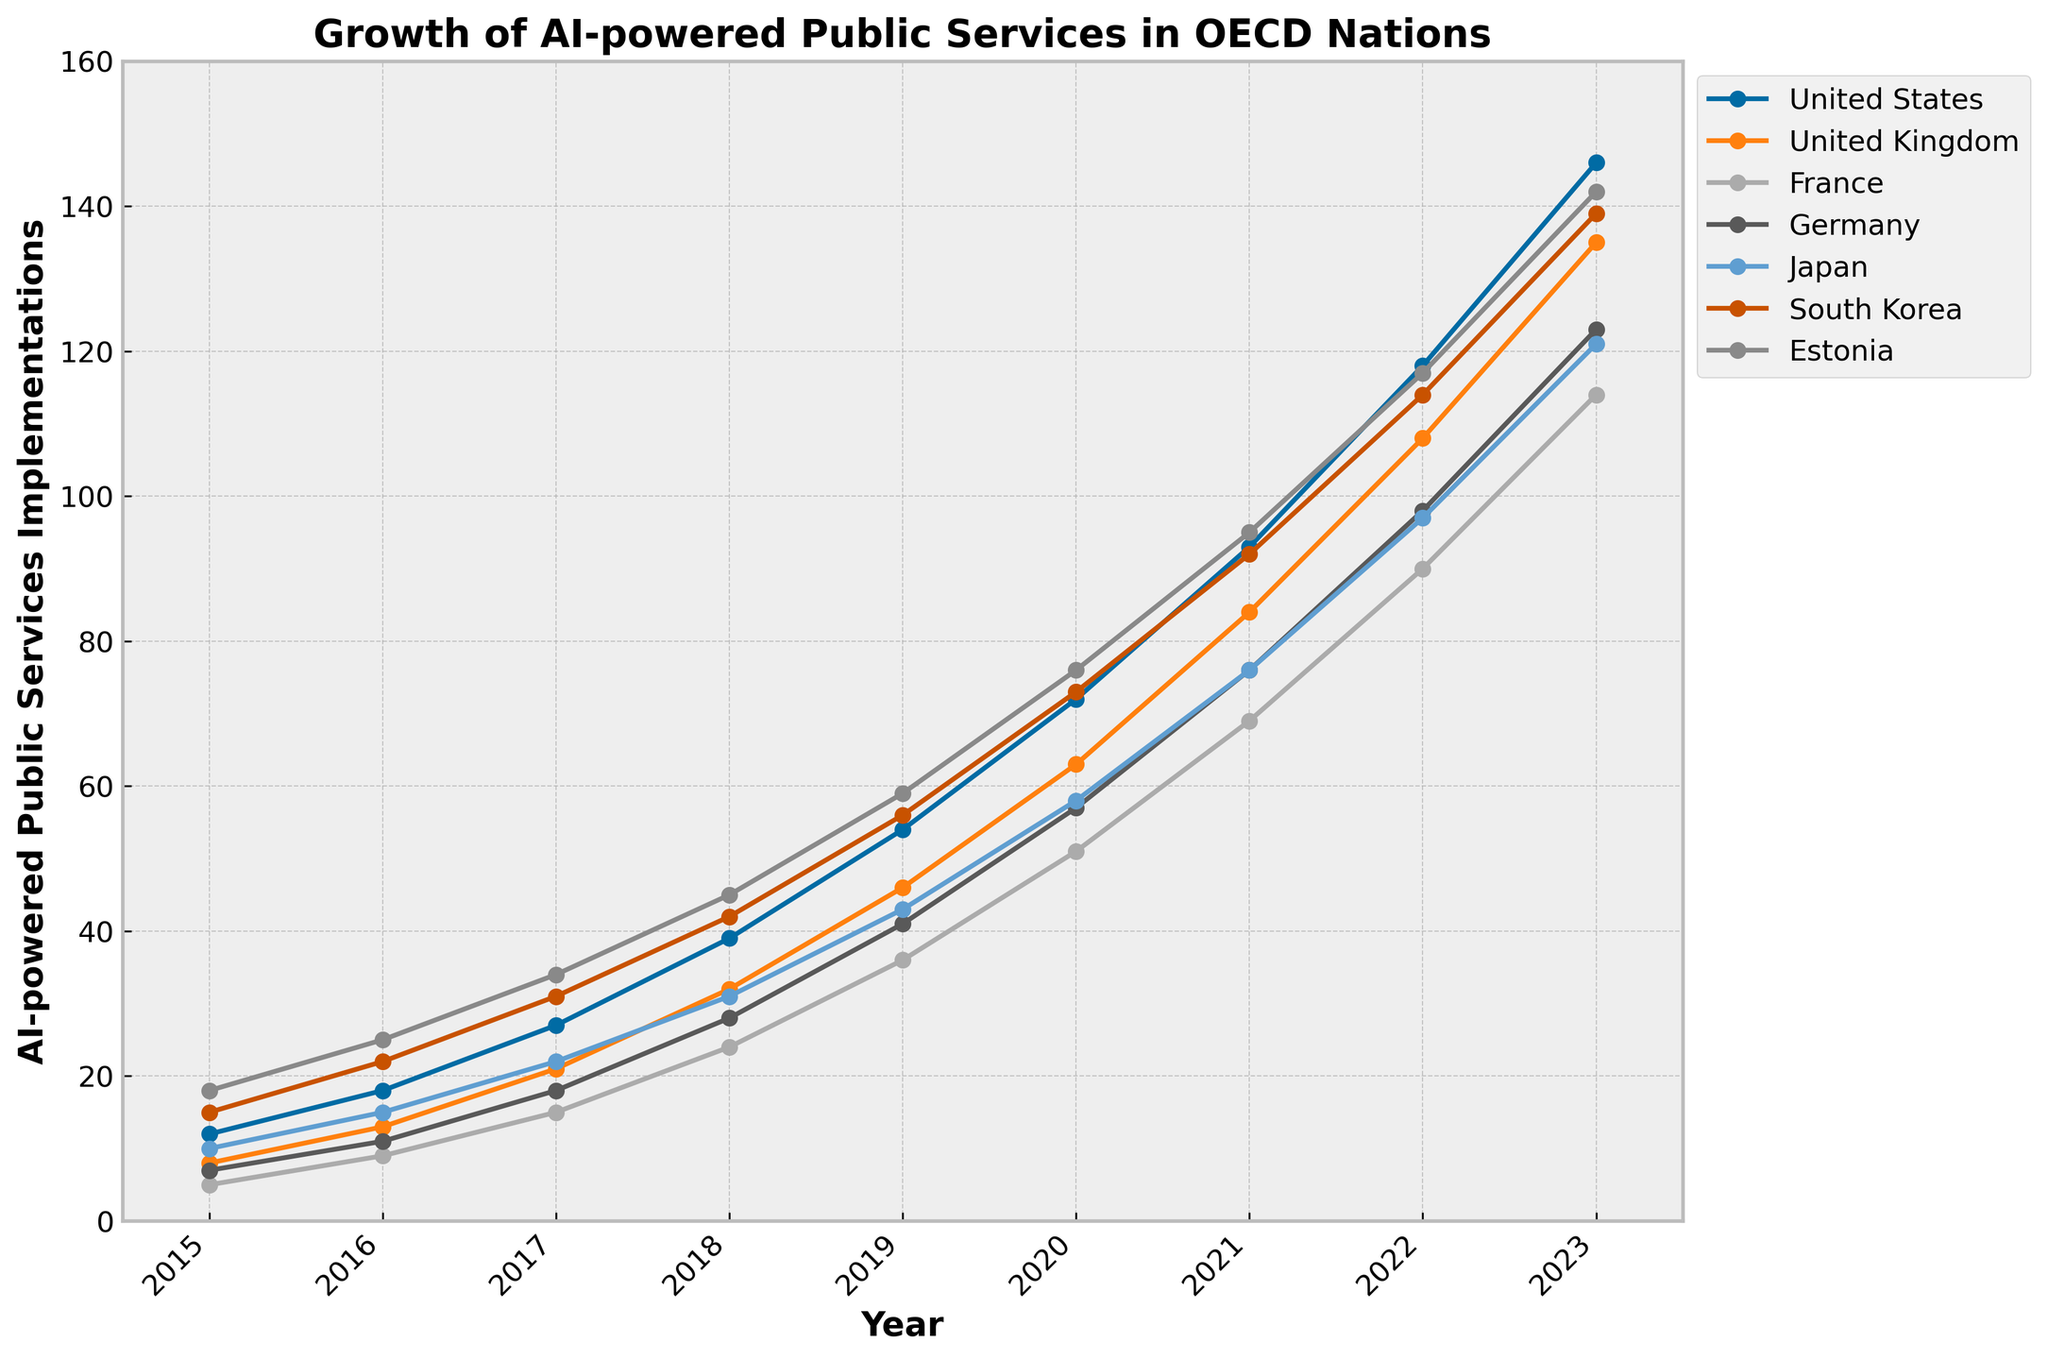Which country showed the sharpest increase in AI-powered public services implementations between 2015 and 2023? Look at the overall trend lines on the chart. Estimate the differences in the ending and starting values for each country. The United States shows the sharpest increase from 12 in 2015 to 146 in 2023.
Answer: United States How many more implementations did South Korea have compared to Germany in 2020? Identify the values for South Korea and Germany in 2020. South Korea has 73 implementations, and Germany has 57, so the difference is 73 - 57 = 16.
Answer: 16 What is the average number of implementations for Japan across the years shown? Sum the values for Japan from 2015 to 2023 and divide by the number of years (9). The total is 10 + 15 + 22 + 31 + 43 + 58 + 76 + 97 + 121 = 373. The average is 373 / 9 ≈ 41.4.
Answer: 41.4 Which country had the least implementations in 2017? Identify the implementation values for each country in 2017 and compare them. France had the least implementations with 15.
Answer: France In which year did Estonia surpass 100 implementations? Look for the point where Estonia's trend line crosses 100. This occurs in 2021 when Estonia reaches 95 and 2022 when it reaches 117.
Answer: 2022 By how much did the United States' implementations increase from 2018 to 2023? Subtract the value in 2018 from the value in 2023 for the United States. The increase is 146 - 39 = 107.
Answer: 107 Which two countries had the same number of implementations in 2021? Compare the implementation numbers for each country in 2021. Japan and Estonia both have 95 implementations.
Answer: Japan and Estonia Rank the countries in descending order of their 2023 implementation count. Check the 2023 values for all countries and order them. The order is: United States (146), South Korea (139), United Kingdom (135), Estonia (142), Germany (123), Japan (121), France (114).
Answer: United States, South Korea, United Kingdom, Estonia, Germany, Japan, France What was the percentage increase in AI-powered public services implementations in the UK from 2015 to 2020? Calculate the increase and the starting value, then find the percentage. The difference is 63 - 8 = 55. The percentage increase is (55 / 8) * 100 ≈ 687.5%.
Answer: 687.5% How many implementations did France have cumulatively from 2015 to 2023? Sum the values for France for each year. The total is 5 + 9 + 15 + 24 + 36 + 51 + 69 + 90 + 114 = 413.
Answer: 413 